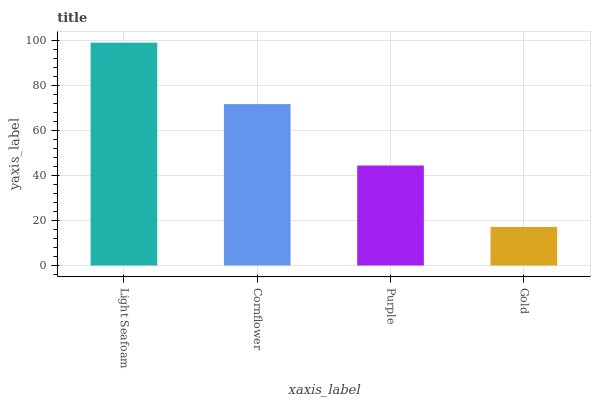Is Gold the minimum?
Answer yes or no. Yes. Is Light Seafoam the maximum?
Answer yes or no. Yes. Is Cornflower the minimum?
Answer yes or no. No. Is Cornflower the maximum?
Answer yes or no. No. Is Light Seafoam greater than Cornflower?
Answer yes or no. Yes. Is Cornflower less than Light Seafoam?
Answer yes or no. Yes. Is Cornflower greater than Light Seafoam?
Answer yes or no. No. Is Light Seafoam less than Cornflower?
Answer yes or no. No. Is Cornflower the high median?
Answer yes or no. Yes. Is Purple the low median?
Answer yes or no. Yes. Is Light Seafoam the high median?
Answer yes or no. No. Is Light Seafoam the low median?
Answer yes or no. No. 